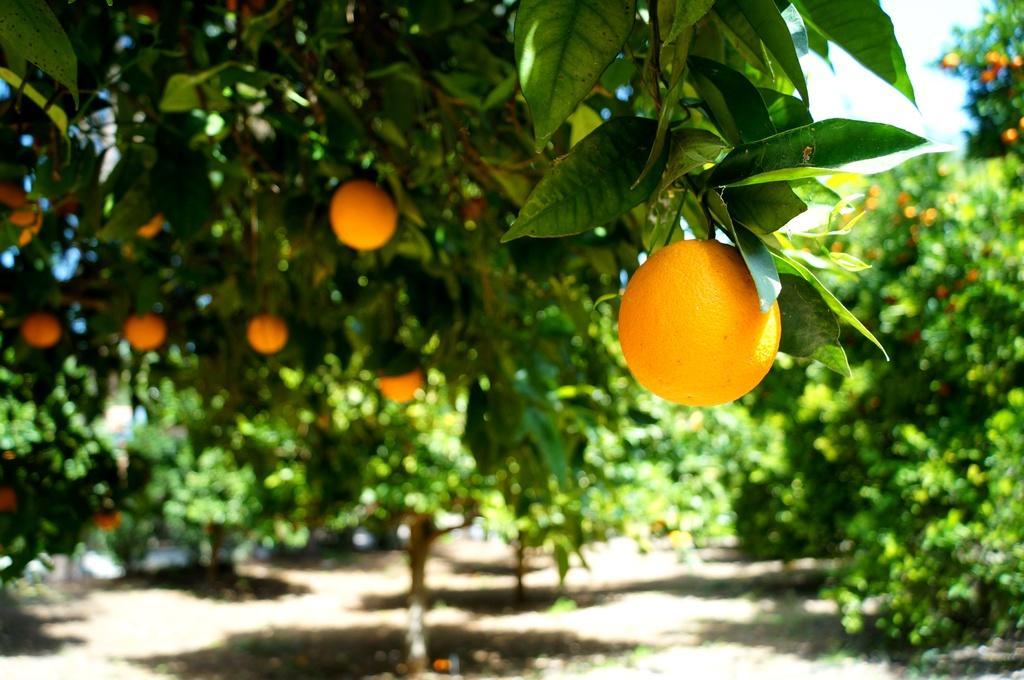Could you give a brief overview of what you see in this image? In the image we can see oranges to the trees, here we can see orange trees, white sky and the background is blurred. 